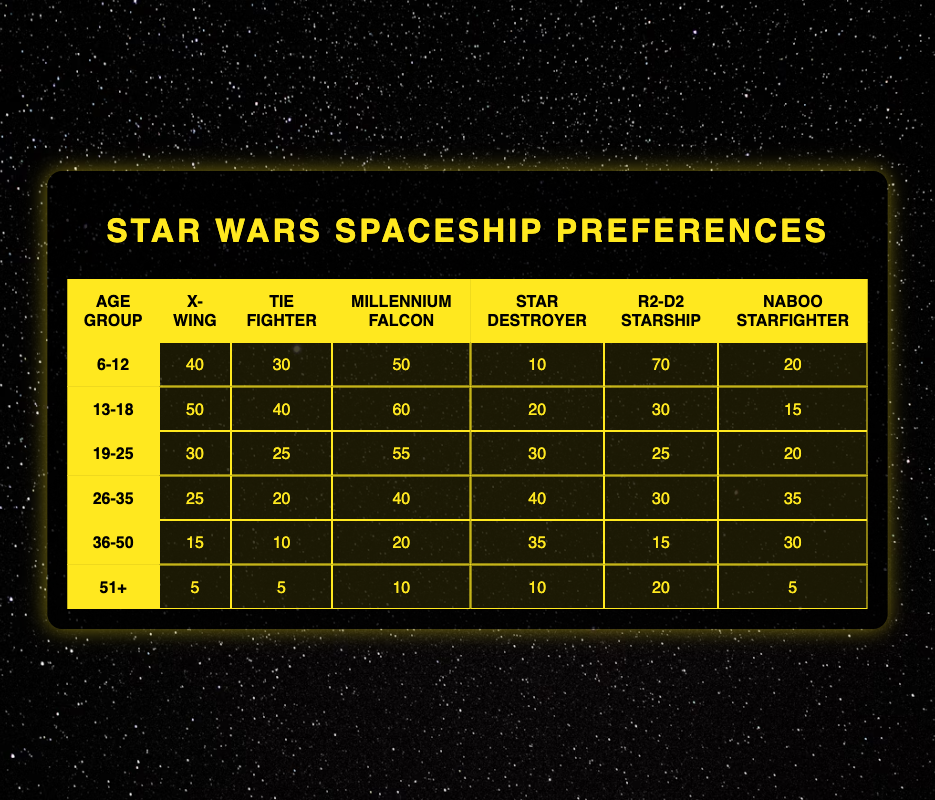What's the most preferred spaceship type for the age group 6-12? In the row for the age group 6-12, the values are: X-Wing (40), Tie Fighter (30), Millennium Falcon (50), Star Destroyer (10), R2-D2 Starship (70), and Naboo Starfighter (20). The highest value is for R2-D2 Starship, which is 70.
Answer: R2-D2 Starship Which spaceship type has the least preference among the age group 51+? In the row for the age group 51+, the values are: X-Wing (5), Tie Fighter (5), Millennium Falcon (10), Star Destroyer (10), R2-D2 Starship (20), and Naboo Starfighter (5). The least values (5) are tied between X-Wing, Tie Fighter, and Naboo Starfighter.
Answer: X-Wing, Tie Fighter, and Naboo Starfighter What is the total preference score for the Millennium Falcon across all age groups? To find the total for Millennium Falcon, add the values from all age groups: 50 + 60 + 55 + 40 + 20 + 10 = 235.
Answer: 235 Is it true that more people aged 26-35 prefer the Star Destroyer than those aged 19-25? For age group 26-35, the preference for Star Destroyer is 40, while for age group 19-25, it is 30. Since 40 is greater than 30, the statement is true.
Answer: Yes What is the average preference for Tie Fighters among all age groups? To calculate the average for Tie Fighter, first sum the preferences: 30 + 40 + 25 + 20 + 10 + 5 = 130. Then, divide the total by the number of age groups (6): 130/6 = 21.67, which can be rounded to 22 for simplicity.
Answer: 22 